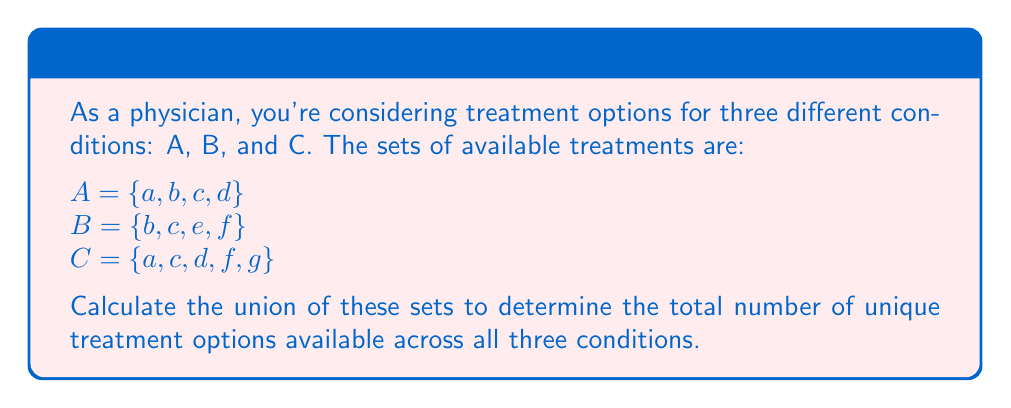What is the answer to this math problem? To solve this problem, we need to find the union of sets A, B, and C. The union of sets includes all unique elements from all sets, without repetition.

Let's approach this step-by-step:

1) First, let's list out all elements from all sets:
   $A \cup B \cup C = \{a, b, c, d, b, c, e, f, a, c, d, f, g\}$

2) Now, we need to eliminate repetitions. Let's count each unique element:
   a: appears 2 times
   b: appears 2 times
   c: appears 3 times
   d: appears 2 times
   e: appears 1 time
   f: appears 2 times
   g: appears 1 time

3) After removing repetitions, we get:
   $A \cup B \cup C = \{a, b, c, d, e, f, g\}$

4) To find the total number of unique treatment options, we count the elements in this final set.

Therefore, there are 7 unique treatment options available across all three conditions.
Answer: The union of the sets is $A \cup B \cup C = \{a, b, c, d, e, f, g\}$, containing 7 elements. 